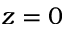<formula> <loc_0><loc_0><loc_500><loc_500>z = 0</formula> 